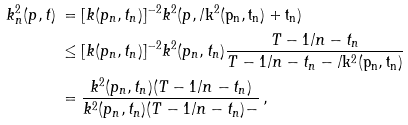<formula> <loc_0><loc_0><loc_500><loc_500>k ^ { 2 } _ { n } ( p , t ) & \, = [ k ( p _ { n } , t _ { n } ) ] ^ { - 2 } k ^ { 2 } ( p , \tt / k ^ { 2 } ( p _ { n } , t _ { n } ) + t _ { n } ) \\ & \, \leq [ k ( p _ { n } , t _ { n } ) ] ^ { - 2 } k ^ { 2 } ( p _ { n } , t _ { n } ) \frac { T - 1 / n - t _ { n } } { T - 1 / n - t _ { n } - \tt / k ^ { 2 } ( p _ { n } , t _ { n } ) } \\ & \, = \frac { k ^ { 2 } ( p _ { n } , t _ { n } ) ( T - 1 / n - t _ { n } ) } { k ^ { 2 } ( p _ { n } , t _ { n } ) ( T - 1 / n - t _ { n } ) - \tt } \, ,</formula> 